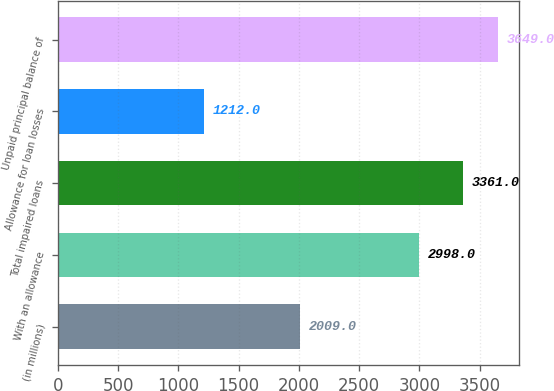Convert chart to OTSL. <chart><loc_0><loc_0><loc_500><loc_500><bar_chart><fcel>(in millions)<fcel>With an allowance<fcel>Total impaired loans<fcel>Allowance for loan losses<fcel>Unpaid principal balance of<nl><fcel>2009<fcel>2998<fcel>3361<fcel>1212<fcel>3649<nl></chart> 